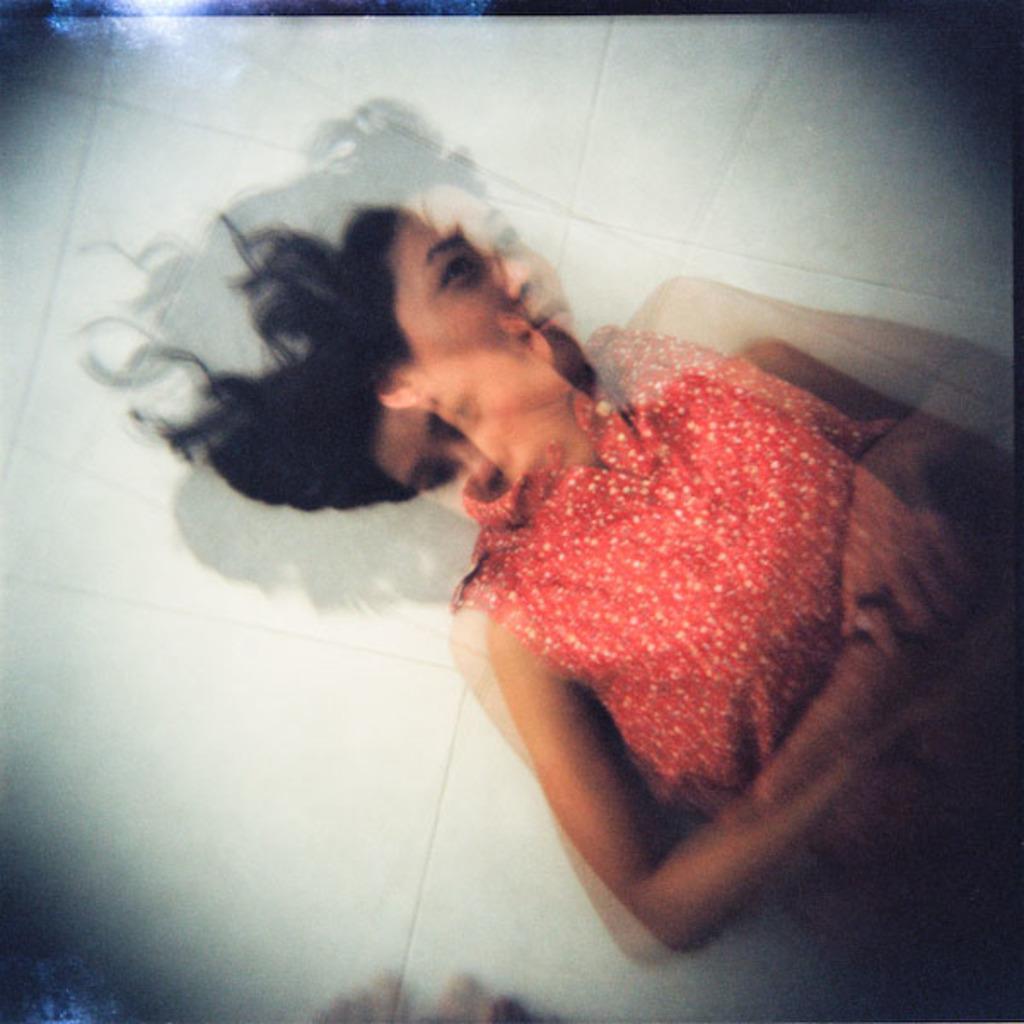Please provide a concise description of this image. In this image I can see a person wearing orange color dress. Background is in white color. 